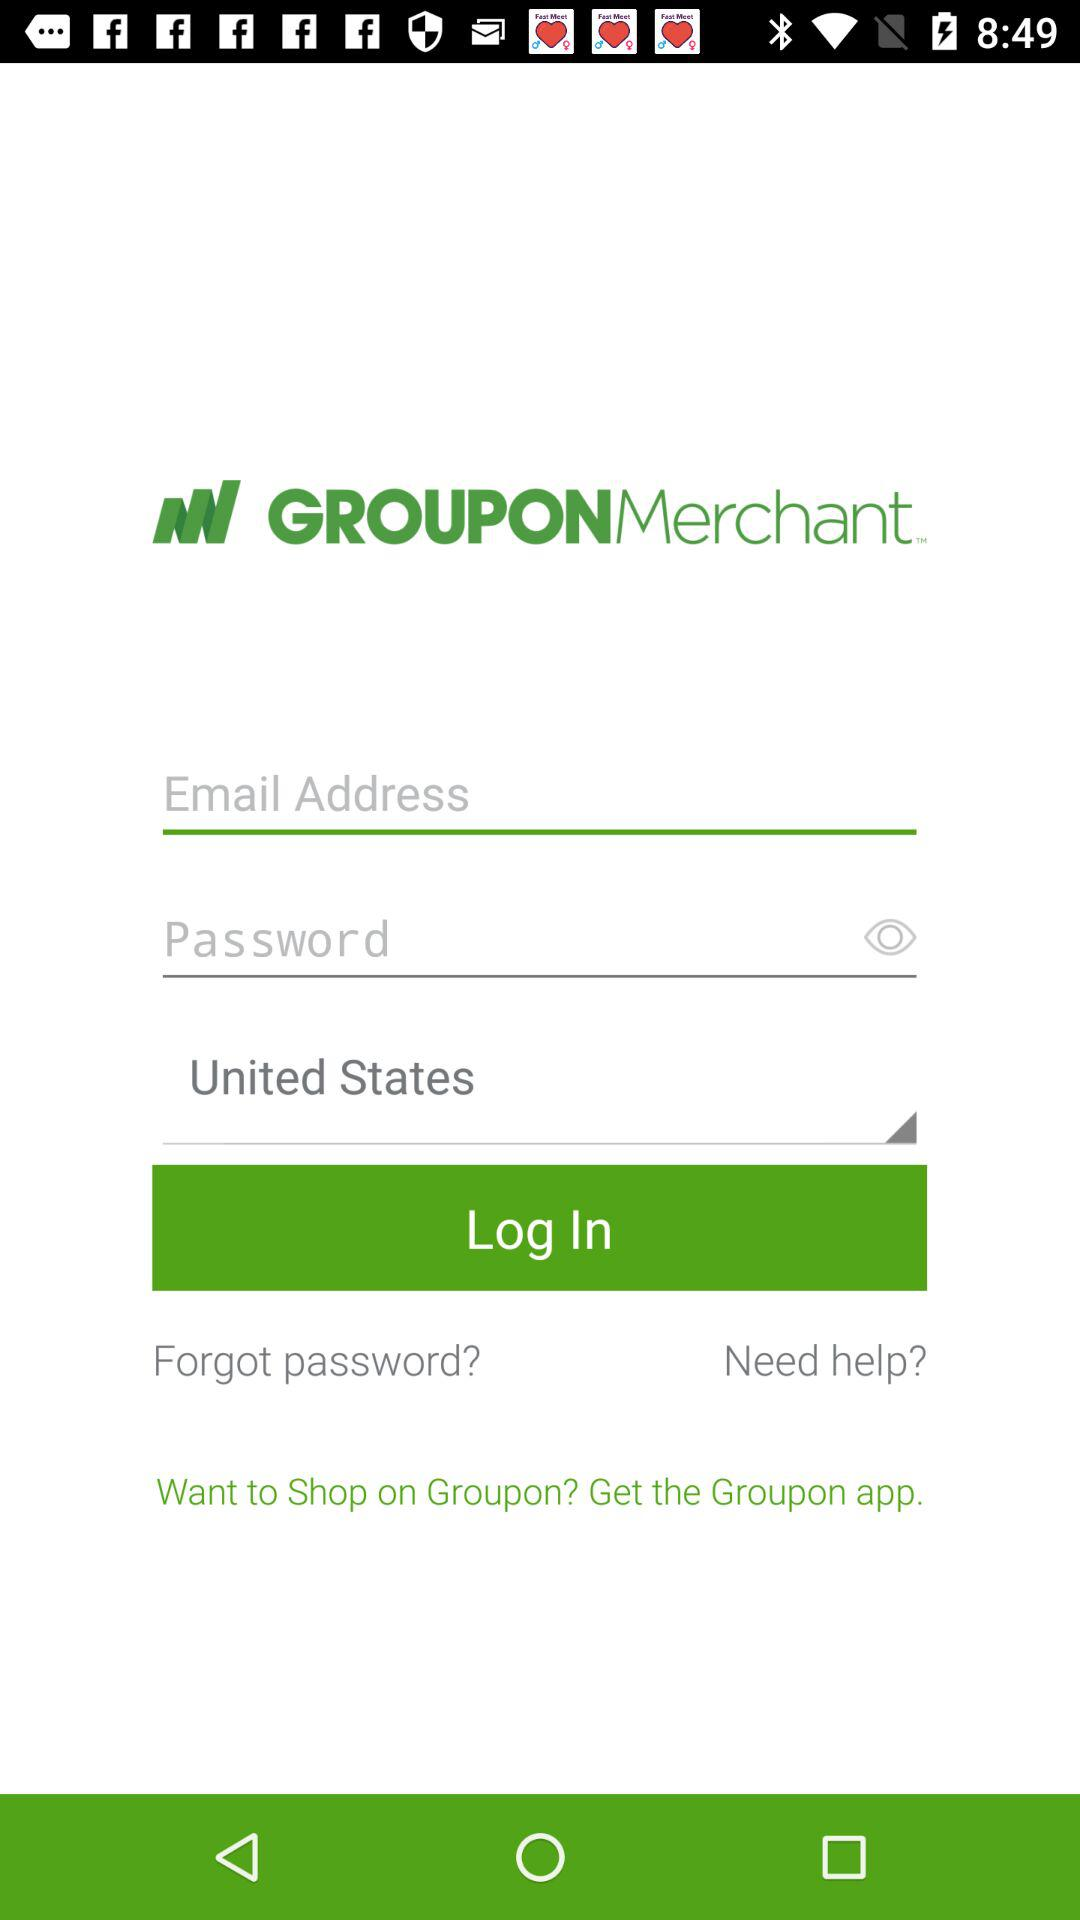What is the application name? The application name is "GROUPONMerchant". 